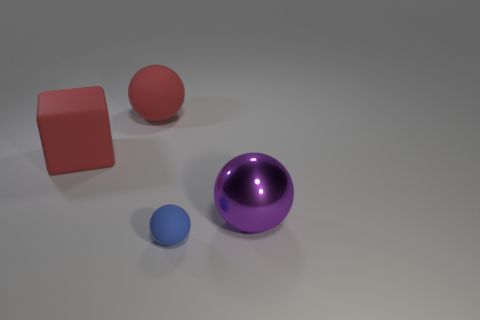What is the size of the block that is the same color as the big rubber sphere?
Provide a succinct answer. Large. Do the big matte block and the big matte sphere have the same color?
Offer a terse response. Yes. What shape is the big matte thing that is the same color as the matte cube?
Offer a very short reply. Sphere. What number of balls are there?
Your response must be concise. 3. What shape is the tiny thing that is the same material as the large red block?
Your response must be concise. Sphere. How big is the matte thing that is on the right side of the object behind the large block?
Offer a very short reply. Small. How many objects are either rubber spheres behind the metallic sphere or rubber objects behind the small matte thing?
Your response must be concise. 2. Are there fewer blocks than red objects?
Your response must be concise. Yes. What number of objects are large cubes or gray cylinders?
Your answer should be compact. 1. Do the big metal thing and the blue thing have the same shape?
Offer a terse response. Yes. 